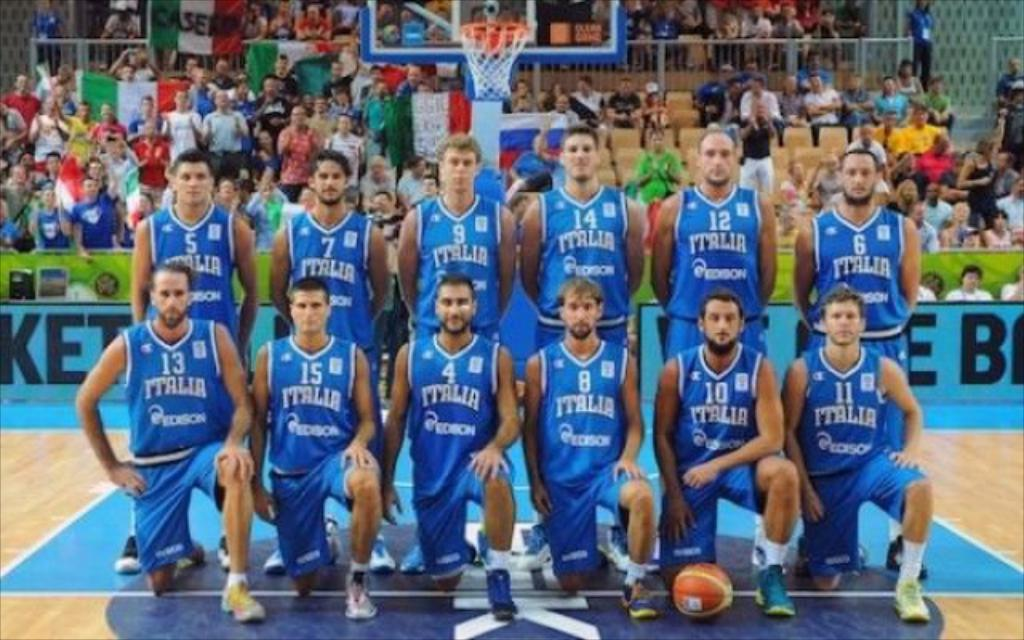<image>
Present a compact description of the photo's key features. italia players in blue posing for photo on basketball court 